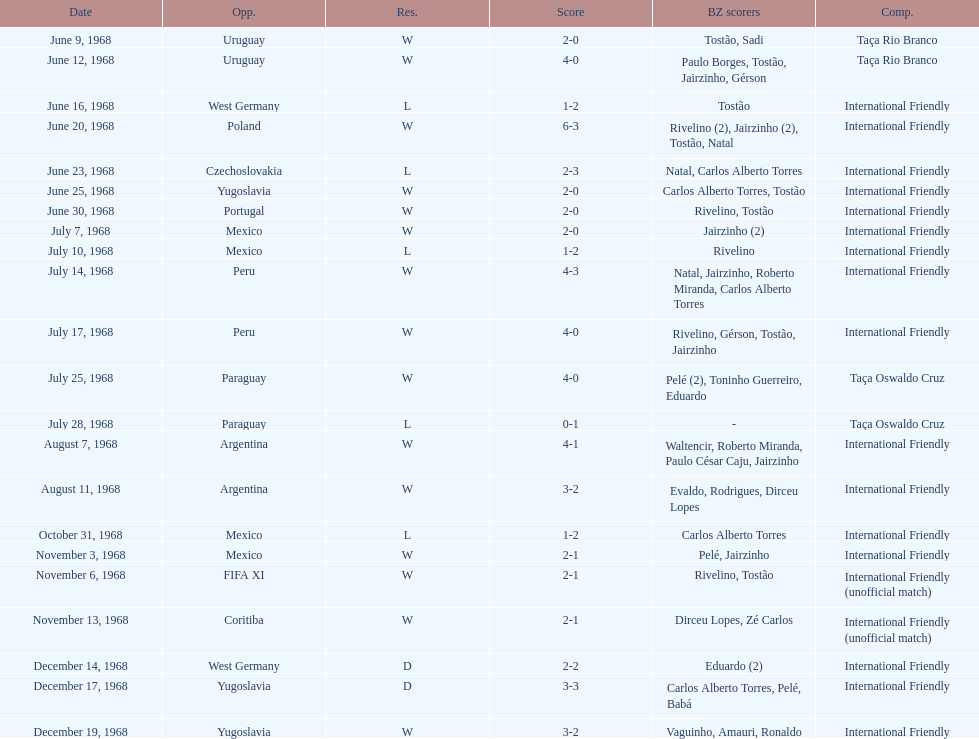What's the total number of ties? 2. 